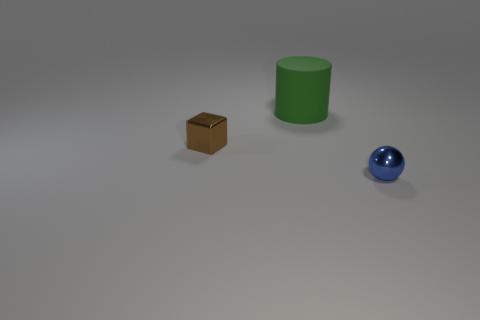Add 2 green cylinders. How many objects exist? 5 Subtract all blocks. How many objects are left? 2 Add 1 large yellow things. How many large yellow things exist? 1 Subtract 0 brown balls. How many objects are left? 3 Subtract all small metal balls. Subtract all brown metal cubes. How many objects are left? 1 Add 1 tiny metal cubes. How many tiny metal cubes are left? 2 